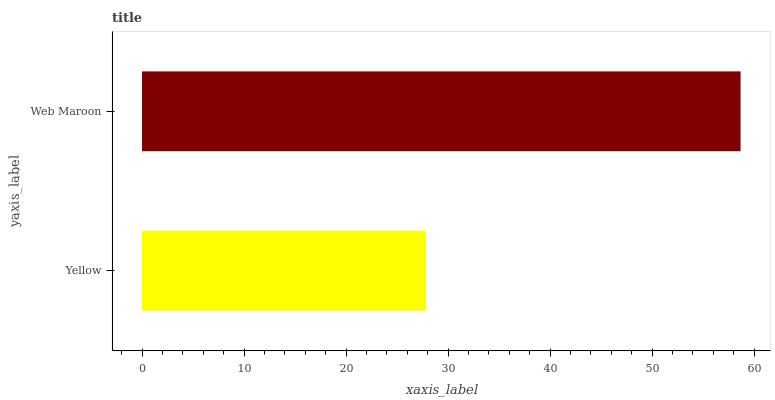Is Yellow the minimum?
Answer yes or no. Yes. Is Web Maroon the maximum?
Answer yes or no. Yes. Is Web Maroon the minimum?
Answer yes or no. No. Is Web Maroon greater than Yellow?
Answer yes or no. Yes. Is Yellow less than Web Maroon?
Answer yes or no. Yes. Is Yellow greater than Web Maroon?
Answer yes or no. No. Is Web Maroon less than Yellow?
Answer yes or no. No. Is Web Maroon the high median?
Answer yes or no. Yes. Is Yellow the low median?
Answer yes or no. Yes. Is Yellow the high median?
Answer yes or no. No. Is Web Maroon the low median?
Answer yes or no. No. 